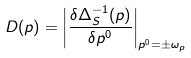<formula> <loc_0><loc_0><loc_500><loc_500>D ( { p } ) = \left | \frac { \delta \Delta _ { S } ^ { - 1 } ( p ) } { \delta p ^ { 0 } } \right | _ { p ^ { 0 } = \pm \omega _ { p } }</formula> 